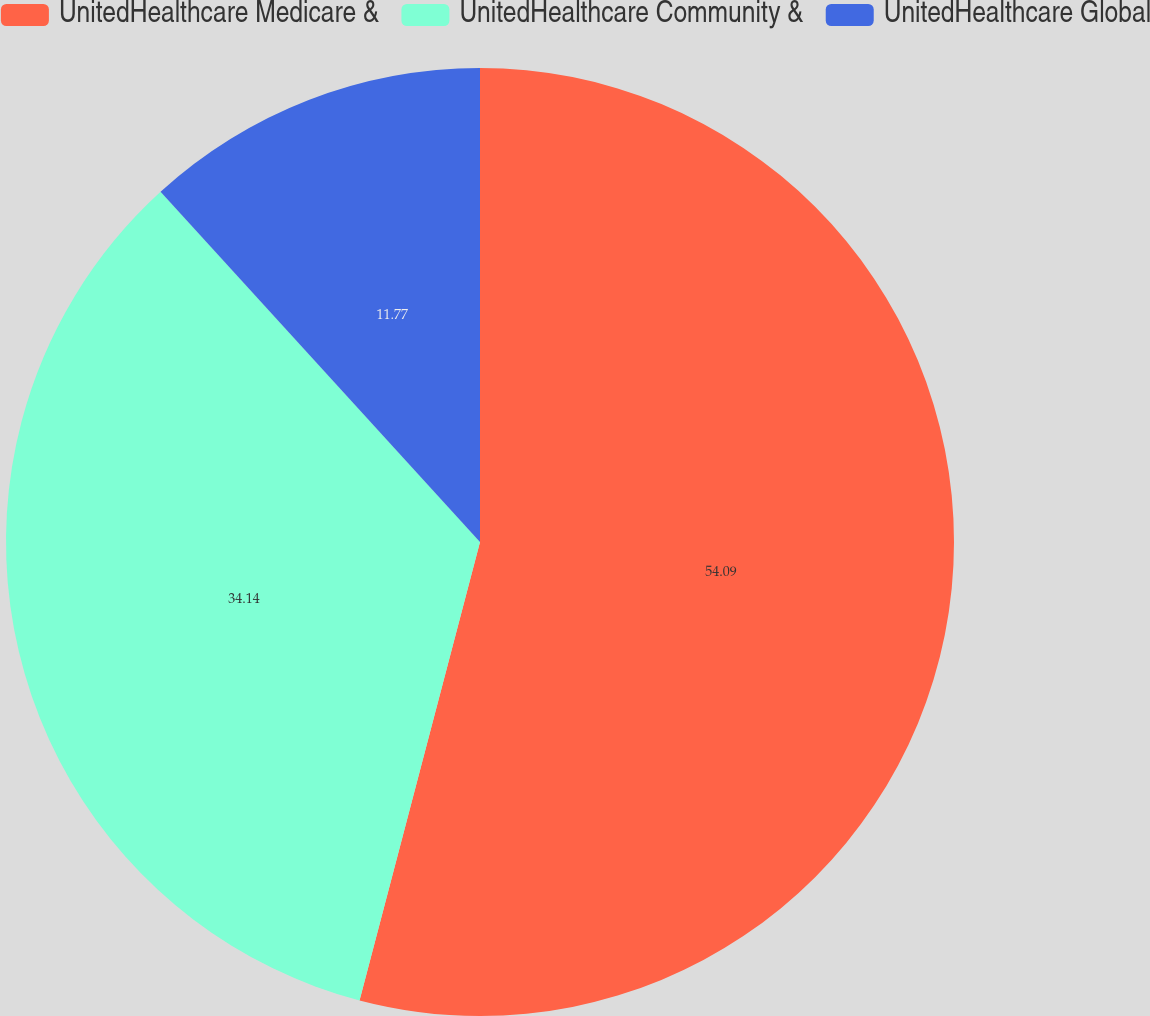<chart> <loc_0><loc_0><loc_500><loc_500><pie_chart><fcel>UnitedHealthcare Medicare &<fcel>UnitedHealthcare Community &<fcel>UnitedHealthcare Global<nl><fcel>54.09%<fcel>34.14%<fcel>11.77%<nl></chart> 